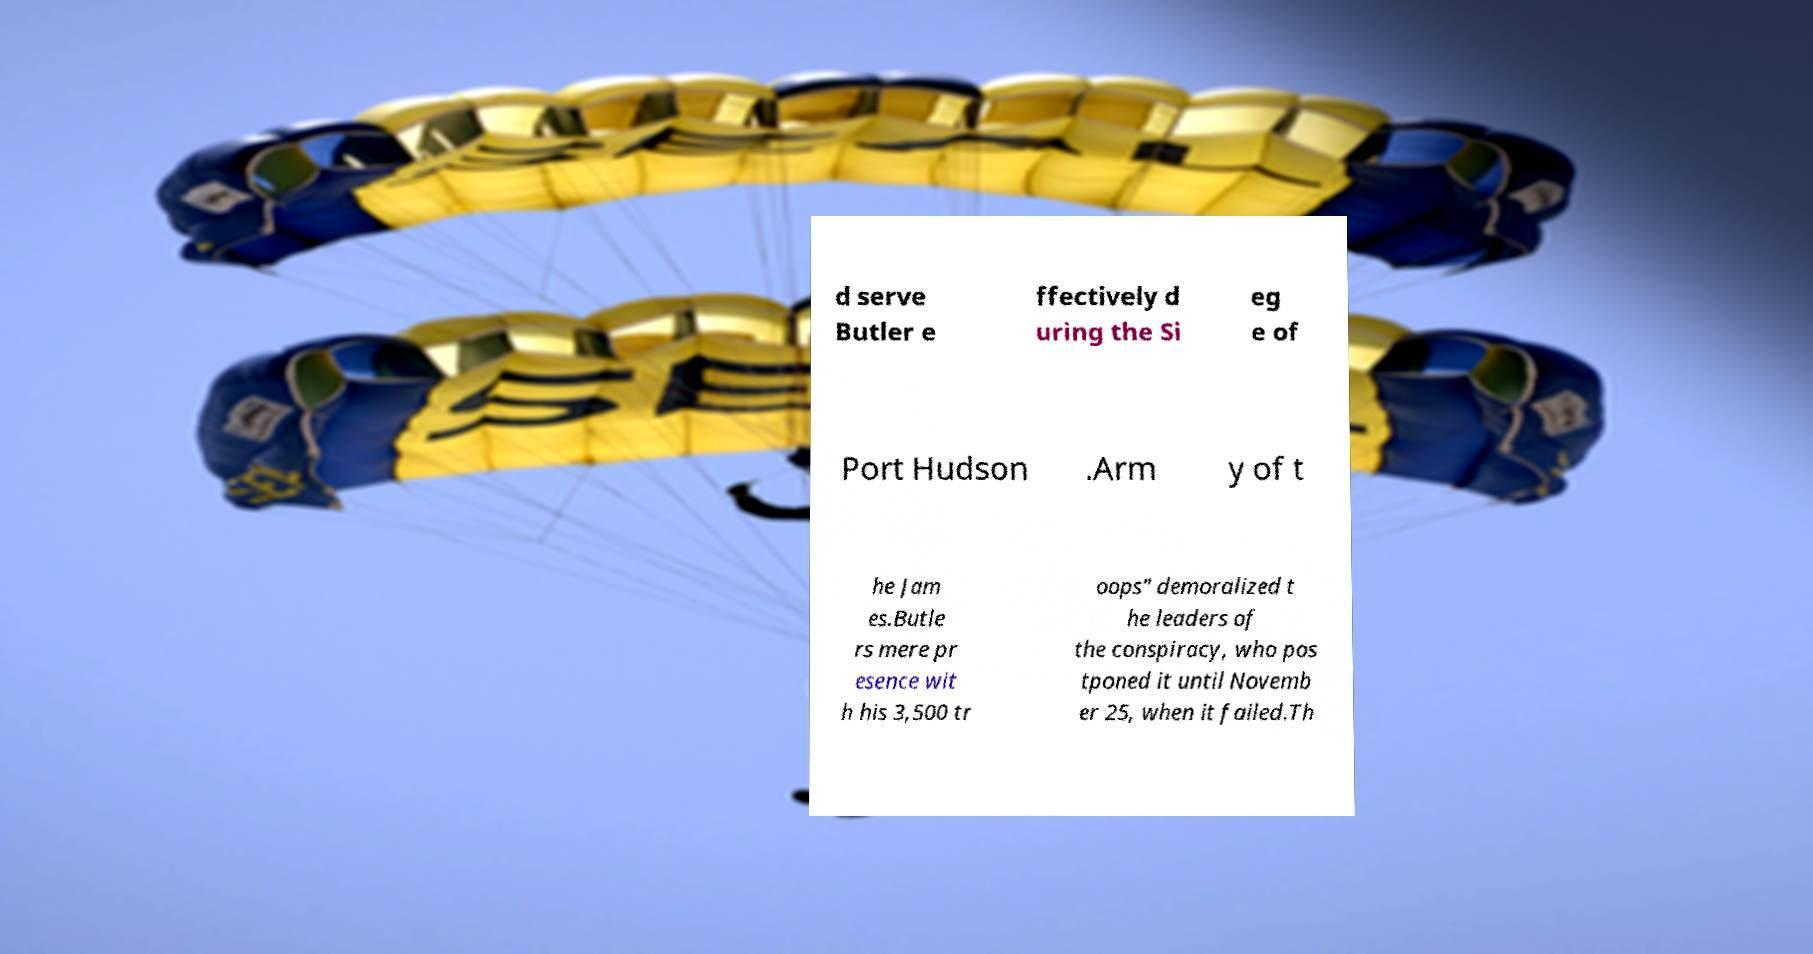What messages or text are displayed in this image? I need them in a readable, typed format. d serve Butler e ffectively d uring the Si eg e of Port Hudson .Arm y of t he Jam es.Butle rs mere pr esence wit h his 3,500 tr oops″ demoralized t he leaders of the conspiracy, who pos tponed it until Novemb er 25, when it failed.Th 